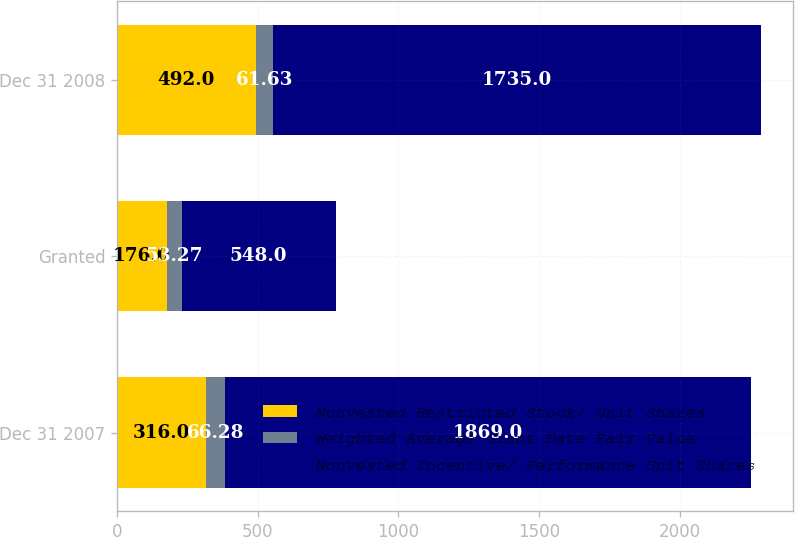Convert chart. <chart><loc_0><loc_0><loc_500><loc_500><stacked_bar_chart><ecel><fcel>Dec 31 2007<fcel>Granted<fcel>Dec 31 2008<nl><fcel>Nonvested Restricted Stock/ Unit Shares<fcel>316<fcel>176<fcel>492<nl><fcel>Weighted Average Grant Date Fair Value<fcel>66.28<fcel>53.27<fcel>61.63<nl><fcel>Nonvested Incentive/ Performance Unit Shares<fcel>1869<fcel>548<fcel>1735<nl></chart> 